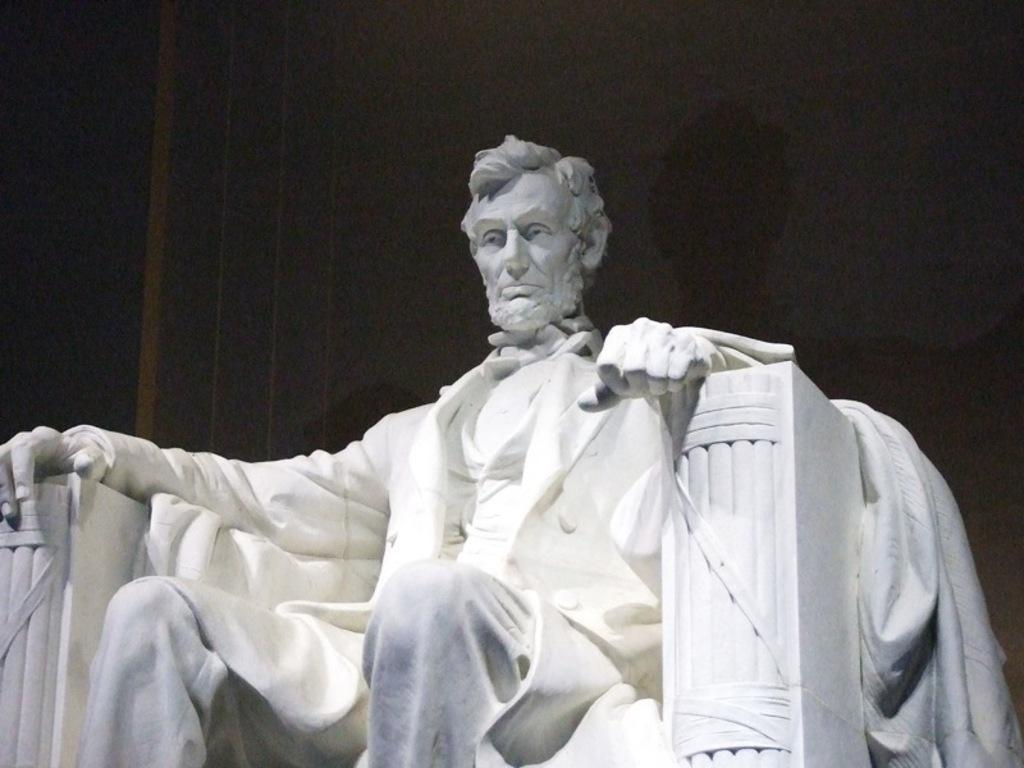Where was the image taken? The image was taken indoors. What can be seen in the background of the image? There is a wall in the background of the image. What is the main subject of the image? There is a sculpture of a man in the middle of the image. What chance did the friends have to win the game in the image? There is no game or friends present in the image; it features a sculpture of a man in an indoor setting with a wall in the background. 